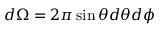Convert formula to latex. <formula><loc_0><loc_0><loc_500><loc_500>d \Omega = 2 \pi \sin \theta d \theta d \phi</formula> 